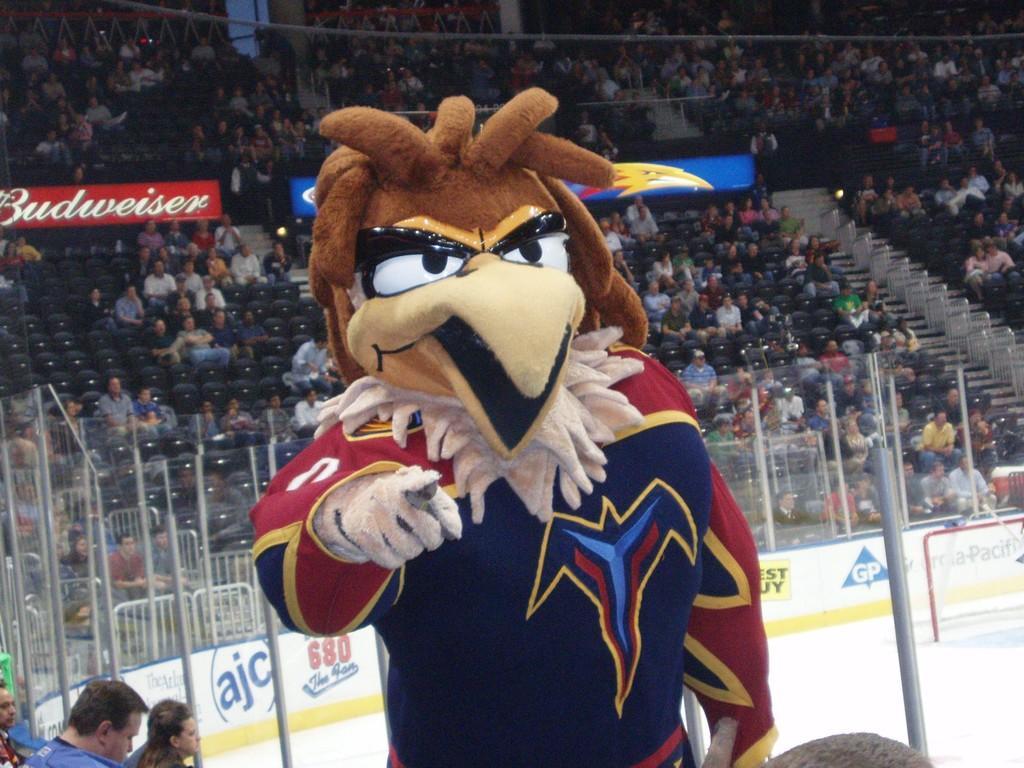Please provide a concise description of this image. Here in this picture we can see a person standing over a place, wearing a costume and behind him we can see number of people sitting in the stands and we can also see fencing covered all over the floor and we can also see goal post with net present on the ice floor and we can also see hoardings present. 